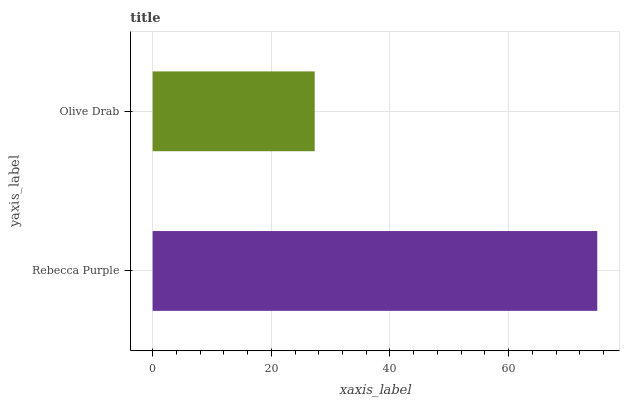Is Olive Drab the minimum?
Answer yes or no. Yes. Is Rebecca Purple the maximum?
Answer yes or no. Yes. Is Olive Drab the maximum?
Answer yes or no. No. Is Rebecca Purple greater than Olive Drab?
Answer yes or no. Yes. Is Olive Drab less than Rebecca Purple?
Answer yes or no. Yes. Is Olive Drab greater than Rebecca Purple?
Answer yes or no. No. Is Rebecca Purple less than Olive Drab?
Answer yes or no. No. Is Rebecca Purple the high median?
Answer yes or no. Yes. Is Olive Drab the low median?
Answer yes or no. Yes. Is Olive Drab the high median?
Answer yes or no. No. Is Rebecca Purple the low median?
Answer yes or no. No. 